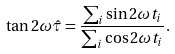<formula> <loc_0><loc_0><loc_500><loc_500>\tan 2 \omega \hat { \tau } = \frac { \sum _ { i } \sin 2 \omega t _ { i } } { \sum _ { i } \cos 2 \omega t _ { i } } .</formula> 